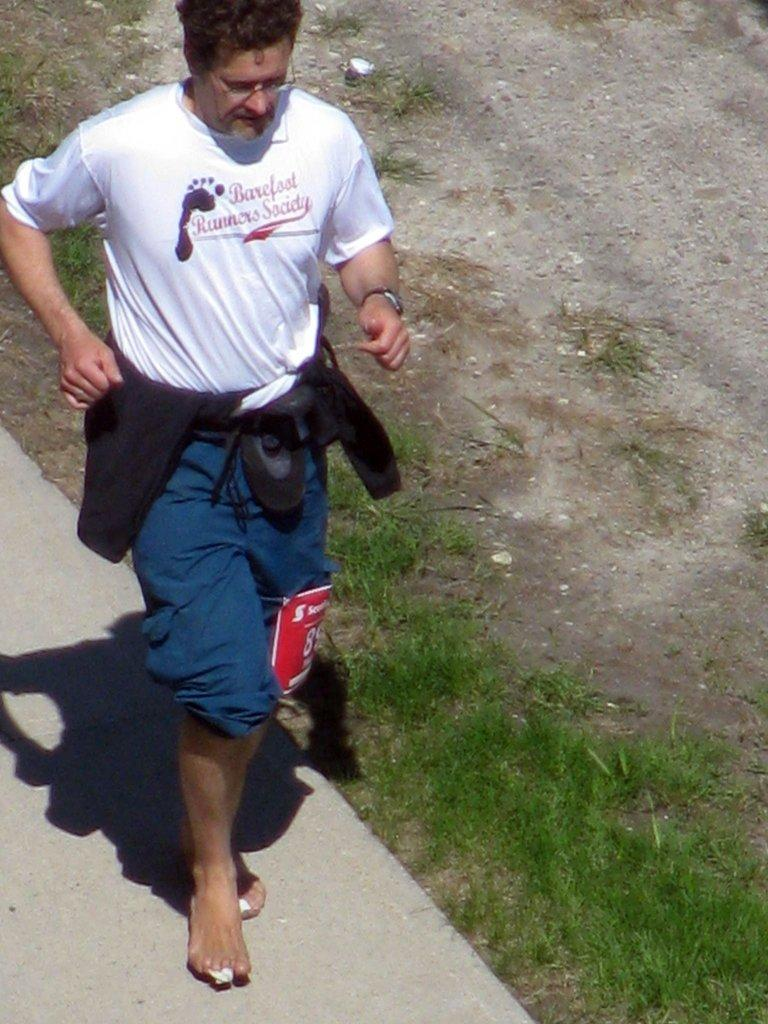Who is present in the image? There is a man in the image. What is the man wearing on his face? The man is wearing glasses. What is attached to the man's knee? There is a text paper tied to the man's knee. What type of vegetation can be seen in the background of the image? There is grass in the background of the image. What can be seen on the ground in the background of the image? The ground is visible in the background of the image. What architectural feature is present in the background of the image? There is a path in the background of the image. What type of yarn is wrapped around the flower in the image? There is no yarn or flower present in the image. 